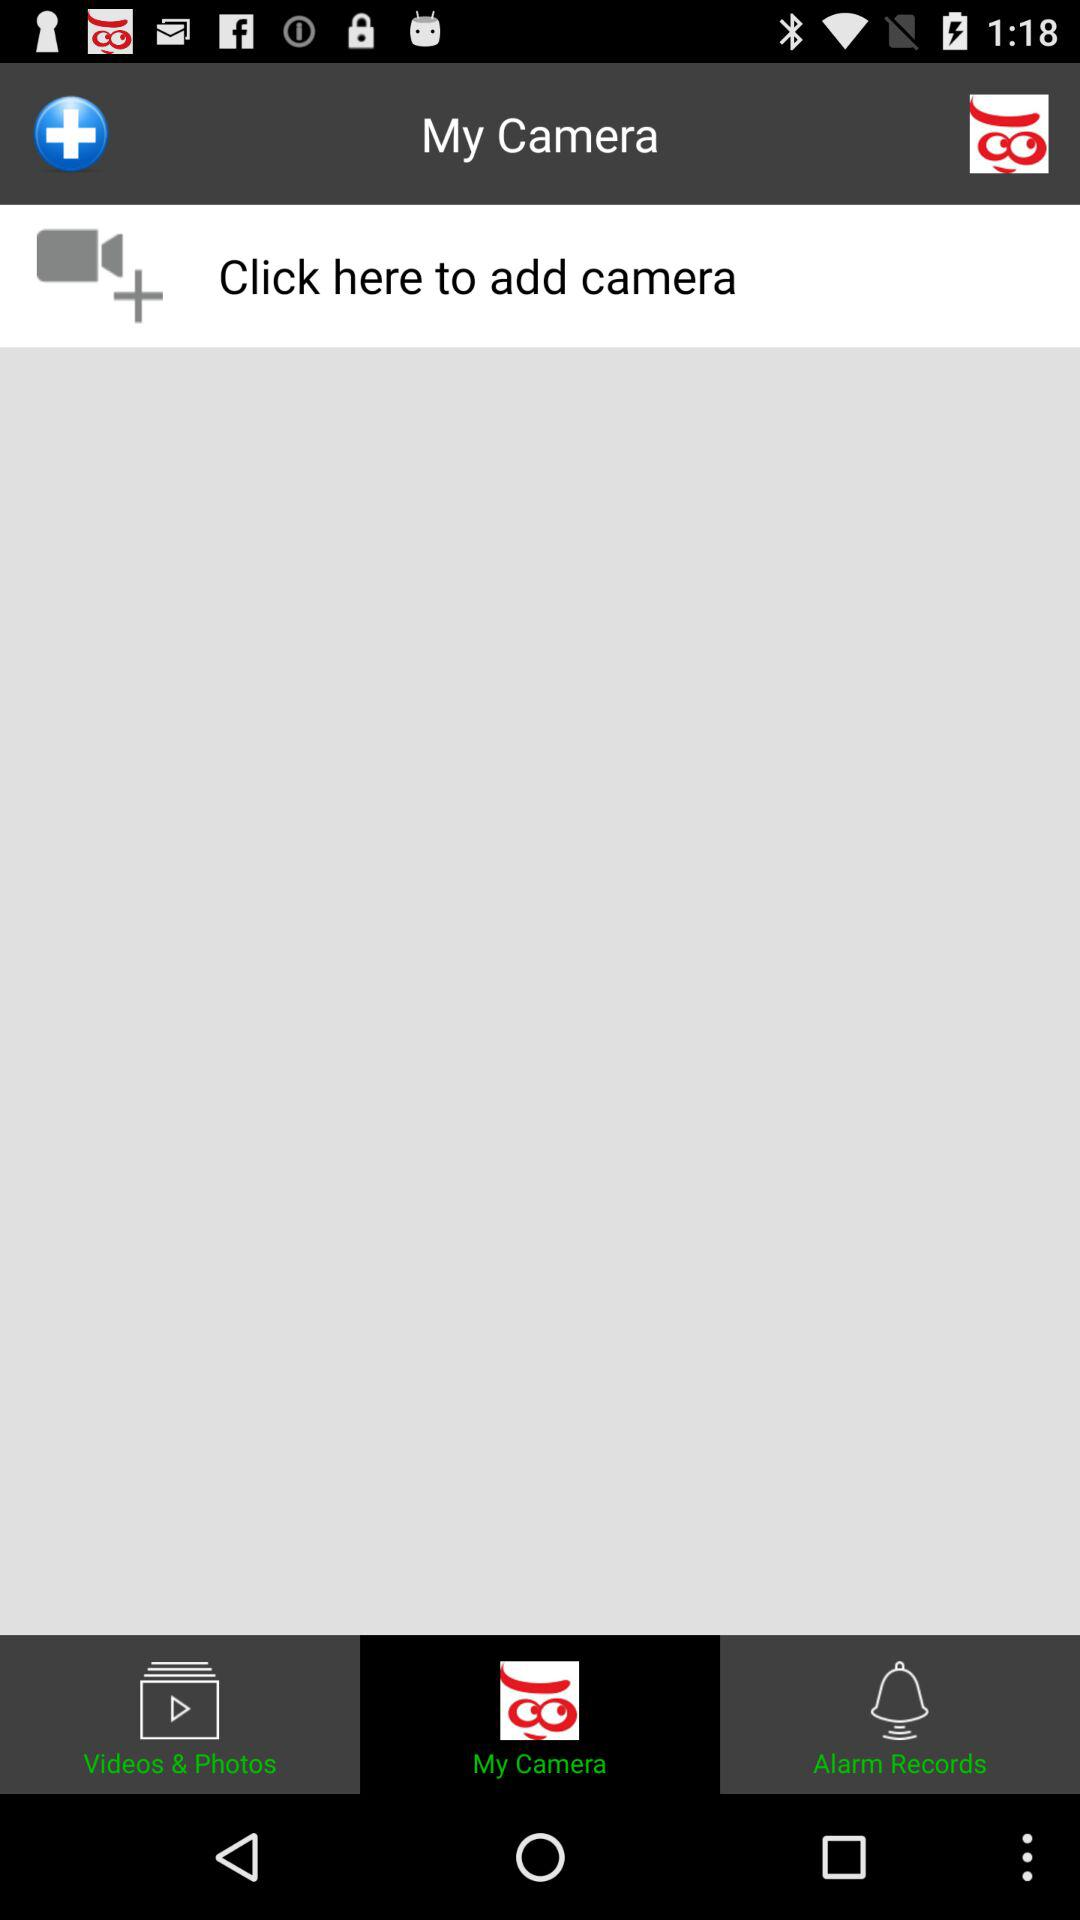Which tab am I on? You are on the "My Camera" tab. 